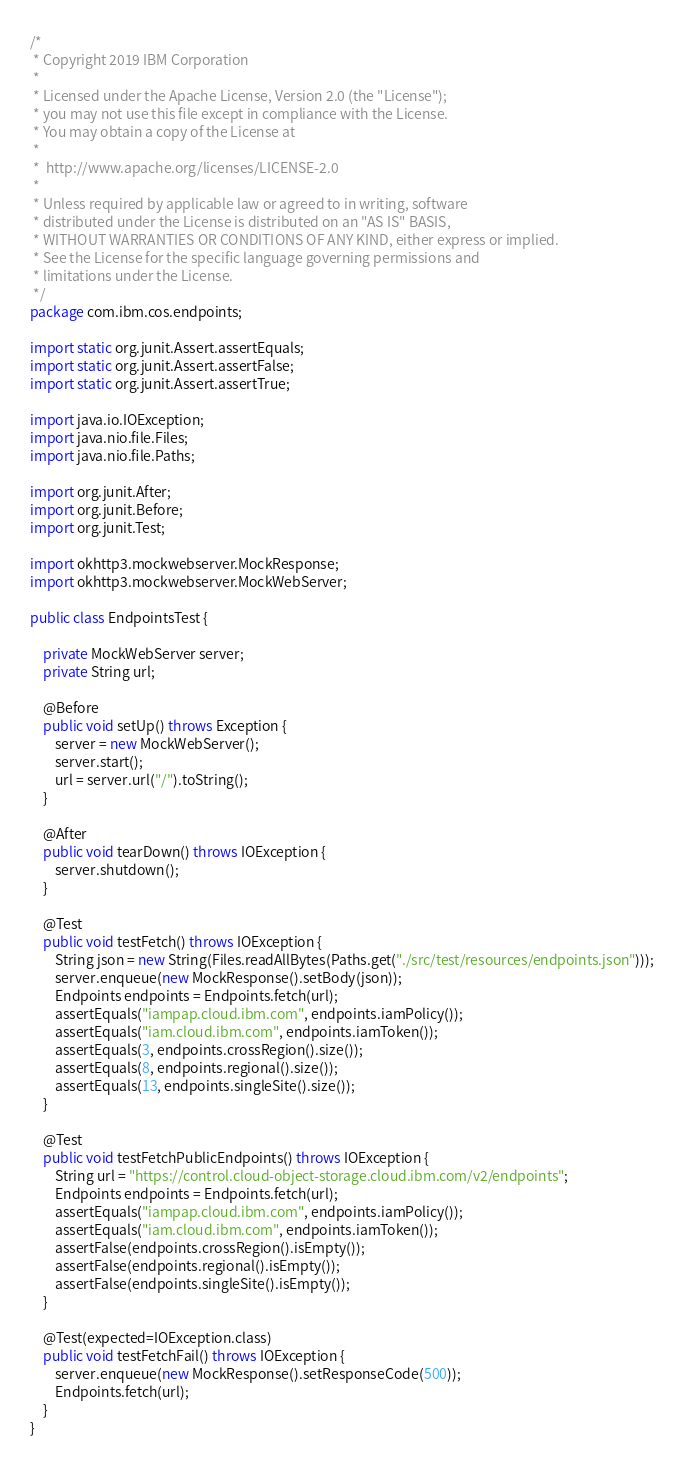Convert code to text. <code><loc_0><loc_0><loc_500><loc_500><_Java_>/*
 * Copyright 2019 IBM Corporation
 *
 * Licensed under the Apache License, Version 2.0 (the "License");
 * you may not use this file except in compliance with the License.
 * You may obtain a copy of the License at
 *
 *  http://www.apache.org/licenses/LICENSE-2.0
 *
 * Unless required by applicable law or agreed to in writing, software
 * distributed under the License is distributed on an "AS IS" BASIS,
 * WITHOUT WARRANTIES OR CONDITIONS OF ANY KIND, either express or implied.
 * See the License for the specific language governing permissions and
 * limitations under the License.
 */
package com.ibm.cos.endpoints;

import static org.junit.Assert.assertEquals;
import static org.junit.Assert.assertFalse;
import static org.junit.Assert.assertTrue;

import java.io.IOException;
import java.nio.file.Files;
import java.nio.file.Paths;

import org.junit.After;
import org.junit.Before;
import org.junit.Test;

import okhttp3.mockwebserver.MockResponse;
import okhttp3.mockwebserver.MockWebServer;

public class EndpointsTest {

    private MockWebServer server;
    private String url;

    @Before
    public void setUp() throws Exception {
        server = new MockWebServer();
        server.start();
        url = server.url("/").toString();
    }

    @After
    public void tearDown() throws IOException {
        server.shutdown();
    }

    @Test
    public void testFetch() throws IOException {
        String json = new String(Files.readAllBytes(Paths.get("./src/test/resources/endpoints.json")));
        server.enqueue(new MockResponse().setBody(json));
        Endpoints endpoints = Endpoints.fetch(url);
        assertEquals("iampap.cloud.ibm.com", endpoints.iamPolicy());
        assertEquals("iam.cloud.ibm.com", endpoints.iamToken());
        assertEquals(3, endpoints.crossRegion().size());
        assertEquals(8, endpoints.regional().size());
        assertEquals(13, endpoints.singleSite().size());
    }

    @Test
    public void testFetchPublicEndpoints() throws IOException {
        String url = "https://control.cloud-object-storage.cloud.ibm.com/v2/endpoints";
        Endpoints endpoints = Endpoints.fetch(url);
        assertEquals("iampap.cloud.ibm.com", endpoints.iamPolicy());
        assertEquals("iam.cloud.ibm.com", endpoints.iamToken());
        assertFalse(endpoints.crossRegion().isEmpty());
        assertFalse(endpoints.regional().isEmpty());
        assertFalse(endpoints.singleSite().isEmpty());
    }

    @Test(expected=IOException.class)
    public void testFetchFail() throws IOException {
        server.enqueue(new MockResponse().setResponseCode(500));
        Endpoints.fetch(url);
    }
}
</code> 